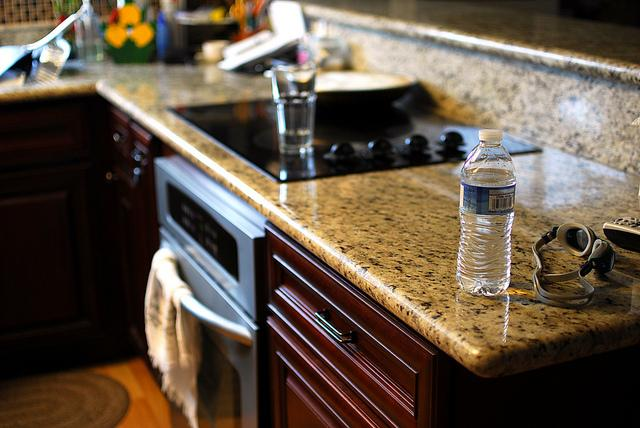The item next to the water bottle is usually used in what setting?

Choices:
A) pool
B) gas station
C) police station
D) school pool 